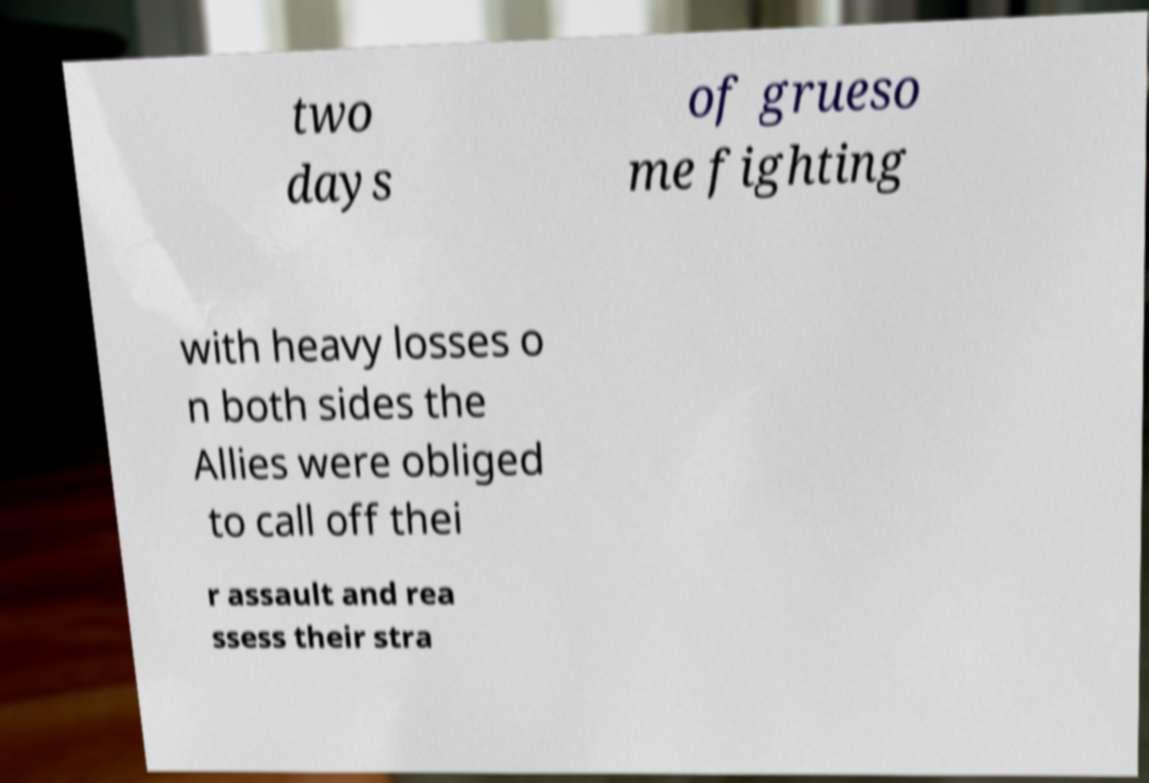For documentation purposes, I need the text within this image transcribed. Could you provide that? two days of grueso me fighting with heavy losses o n both sides the Allies were obliged to call off thei r assault and rea ssess their stra 